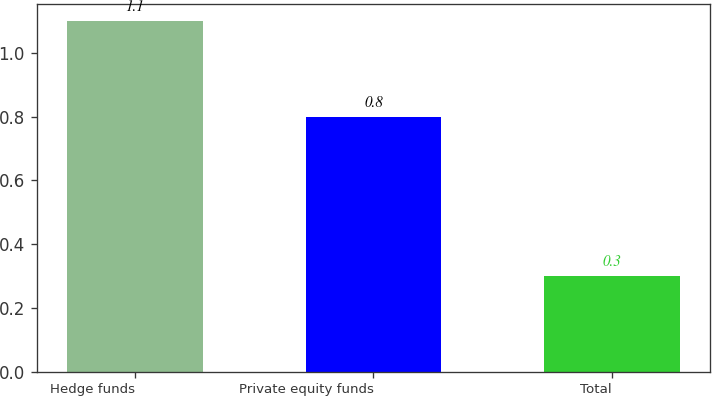Convert chart. <chart><loc_0><loc_0><loc_500><loc_500><bar_chart><fcel>Hedge funds<fcel>Private equity funds<fcel>Total<nl><fcel>1.1<fcel>0.8<fcel>0.3<nl></chart> 